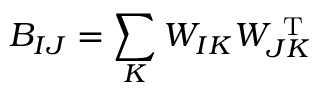Convert formula to latex. <formula><loc_0><loc_0><loc_500><loc_500>B _ { I J } = \sum _ { K } W _ { I K } W _ { J K } ^ { T }</formula> 